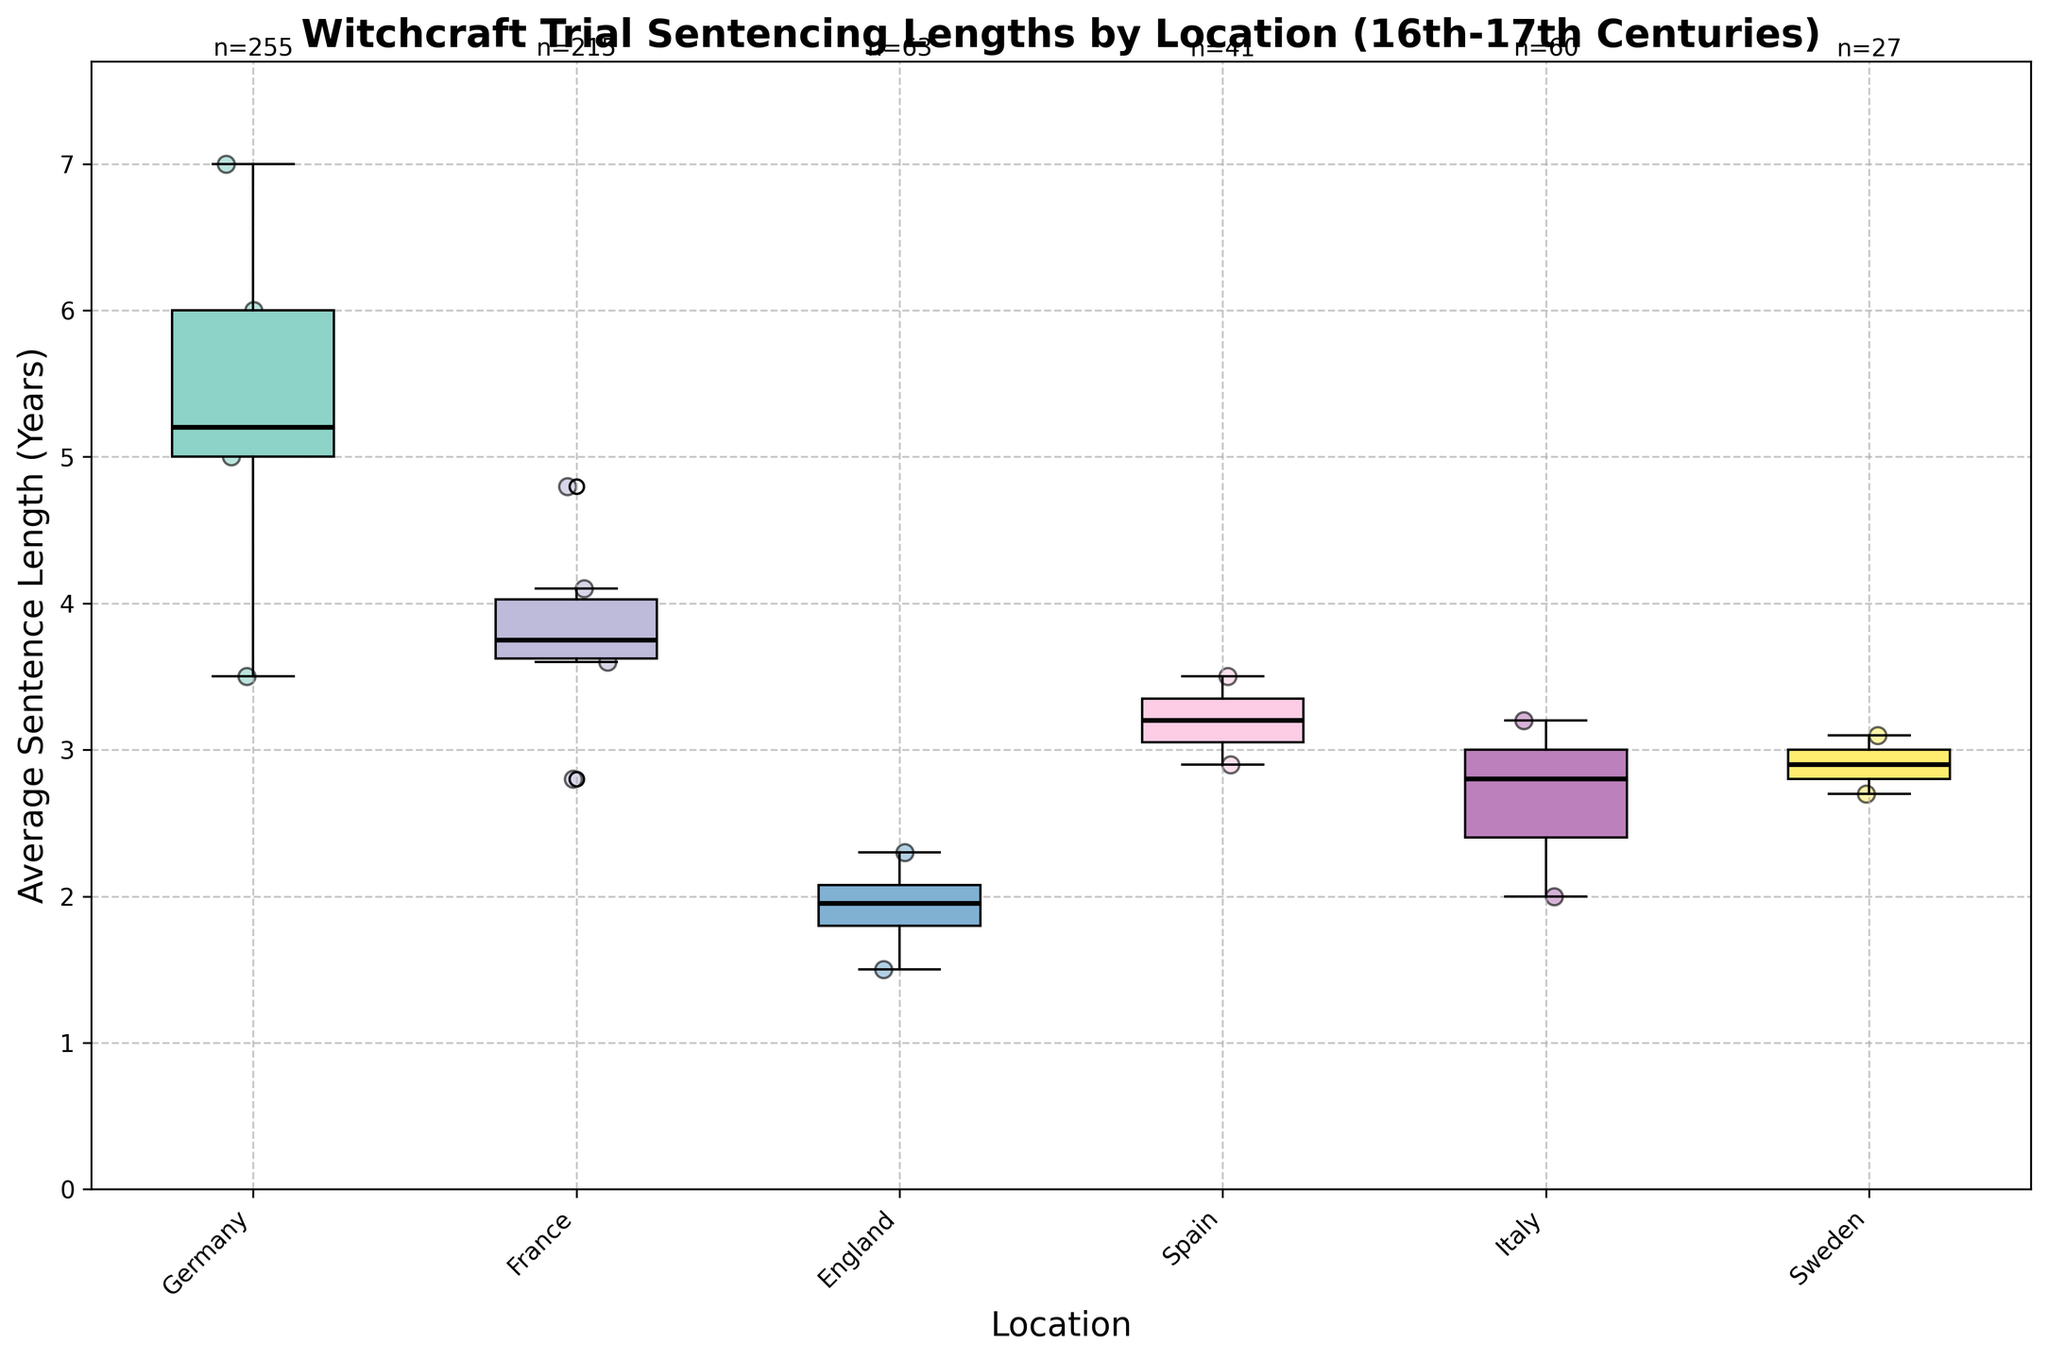What's the title of the figure? The title of the figure is displayed at the top of the plot. It summarizes the overall subject of the data being displayed.
Answer: Witchcraft Trial Sentencing Lengths by Location (16th-17th Centuries) What are the axis labels for the figure? The axis labels provide information about the data being plotted along each axis. The x-axis label is at the bottom and the y-axis label is on the left side of the plot.
Answer: The x-axis label is "Location" and the y-axis label is "Average Sentence Length (Years)" Which location has the highest median sentence length? The median value for each location is shown as a thick line inside the box of the box plot. The location with the highest median will have the median line at the highest y-value.
Answer: Germany In which location is the variability in average sentencing length the smallest? The variability is indicated by the interquartile range (IQR), represented by the height of the box. The location with the smallest IQR has the shortest box.
Answer: England What is the trial count for Germany? The text above each box indicates the trial count for each location. The trial count can be identified directly from this annotation.
Answer: n=255 What is the range of average sentence lengths for France? The range can be identified by looking at the upper and lower whiskers of the box plot for France. The range is the difference between the maximum and minimum points.
Answer: 2.8 to 4.8 years Which location has the lowest outliers in sentence length? Outliers are shown as individual points that fall outside the whiskers. Check for the lowest individual points for each location to identify the one with the lowest outliers.
Answer: Italy How does the average sentence length in Sweden compare to that in England? Compare the position of the median lines within the boxes for Sweden and England. The higher median line indicates a longer average sentence length.
Answer: Sweden has a longer average sentence length than England Order the locations by their median sentence length from shortest to longest. To answer this, compare the median lines in each box. Start from the lowest to the highest median line.
Answer: England, Italy, Sweden, Spain, France, Germany Which location shows the highest amount of variation in sentencing length? Variation in sentencing length is indicated by the height of the box (IQR) and the length of whiskers. The location with the tallest box and/or longest whiskers has the highest variability.
Answer: Germany 